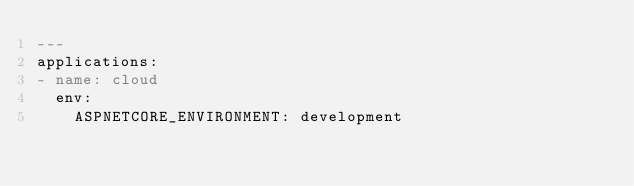Convert code to text. <code><loc_0><loc_0><loc_500><loc_500><_YAML_>---
applications:
- name: cloud
  env:
    ASPNETCORE_ENVIRONMENT: development
</code> 